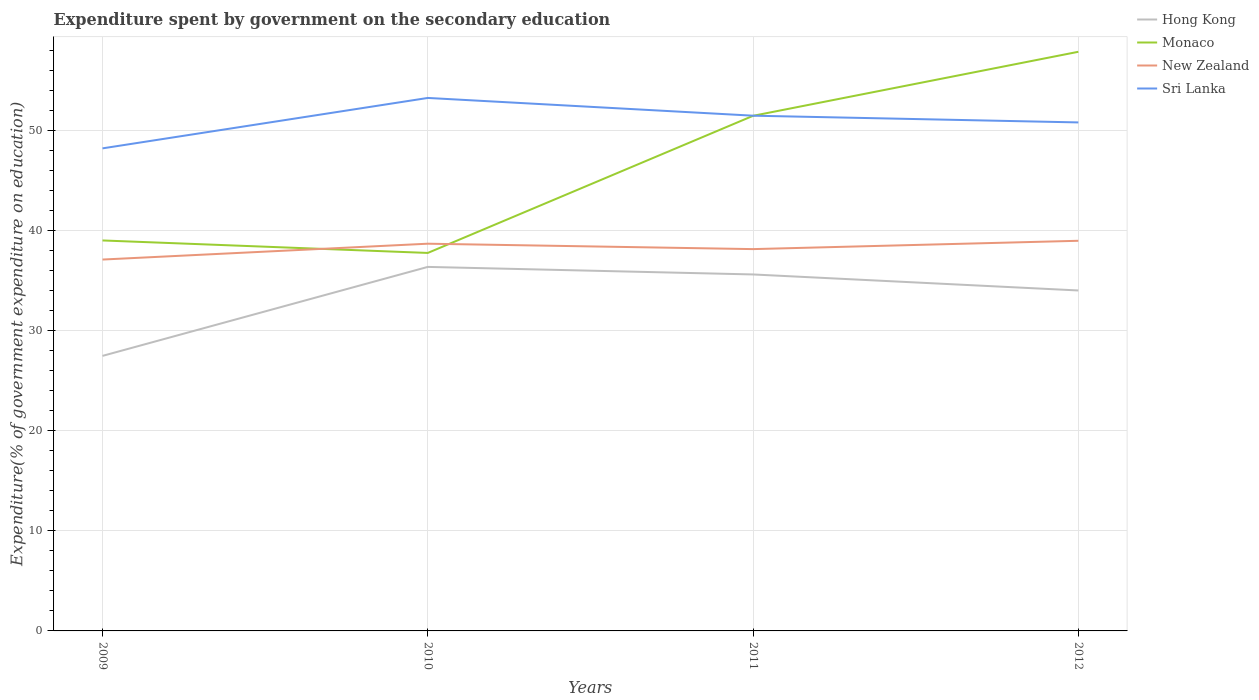Across all years, what is the maximum expenditure spent by government on the secondary education in New Zealand?
Your response must be concise. 37.09. What is the total expenditure spent by government on the secondary education in Monaco in the graph?
Provide a succinct answer. -6.39. What is the difference between the highest and the second highest expenditure spent by government on the secondary education in Hong Kong?
Your answer should be very brief. 8.89. What is the difference between the highest and the lowest expenditure spent by government on the secondary education in Monaco?
Make the answer very short. 2. How many years are there in the graph?
Provide a succinct answer. 4. Does the graph contain grids?
Make the answer very short. Yes. Where does the legend appear in the graph?
Offer a terse response. Top right. What is the title of the graph?
Make the answer very short. Expenditure spent by government on the secondary education. Does "Norway" appear as one of the legend labels in the graph?
Ensure brevity in your answer.  No. What is the label or title of the Y-axis?
Your answer should be compact. Expenditure(% of government expenditure on education). What is the Expenditure(% of government expenditure on education) of Hong Kong in 2009?
Your answer should be compact. 27.47. What is the Expenditure(% of government expenditure on education) in Monaco in 2009?
Your answer should be very brief. 38.99. What is the Expenditure(% of government expenditure on education) of New Zealand in 2009?
Ensure brevity in your answer.  37.09. What is the Expenditure(% of government expenditure on education) of Sri Lanka in 2009?
Give a very brief answer. 48.19. What is the Expenditure(% of government expenditure on education) in Hong Kong in 2010?
Make the answer very short. 36.35. What is the Expenditure(% of government expenditure on education) in Monaco in 2010?
Keep it short and to the point. 37.75. What is the Expenditure(% of government expenditure on education) of New Zealand in 2010?
Provide a short and direct response. 38.67. What is the Expenditure(% of government expenditure on education) of Sri Lanka in 2010?
Your answer should be compact. 53.22. What is the Expenditure(% of government expenditure on education) of Hong Kong in 2011?
Make the answer very short. 35.6. What is the Expenditure(% of government expenditure on education) in Monaco in 2011?
Offer a terse response. 51.44. What is the Expenditure(% of government expenditure on education) of New Zealand in 2011?
Provide a succinct answer. 38.13. What is the Expenditure(% of government expenditure on education) of Sri Lanka in 2011?
Keep it short and to the point. 51.45. What is the Expenditure(% of government expenditure on education) in Hong Kong in 2012?
Make the answer very short. 34. What is the Expenditure(% of government expenditure on education) of Monaco in 2012?
Provide a succinct answer. 57.83. What is the Expenditure(% of government expenditure on education) of New Zealand in 2012?
Your answer should be very brief. 38.96. What is the Expenditure(% of government expenditure on education) of Sri Lanka in 2012?
Your answer should be very brief. 50.78. Across all years, what is the maximum Expenditure(% of government expenditure on education) in Hong Kong?
Offer a very short reply. 36.35. Across all years, what is the maximum Expenditure(% of government expenditure on education) of Monaco?
Your response must be concise. 57.83. Across all years, what is the maximum Expenditure(% of government expenditure on education) of New Zealand?
Your answer should be compact. 38.96. Across all years, what is the maximum Expenditure(% of government expenditure on education) in Sri Lanka?
Your response must be concise. 53.22. Across all years, what is the minimum Expenditure(% of government expenditure on education) of Hong Kong?
Offer a terse response. 27.47. Across all years, what is the minimum Expenditure(% of government expenditure on education) of Monaco?
Ensure brevity in your answer.  37.75. Across all years, what is the minimum Expenditure(% of government expenditure on education) of New Zealand?
Your response must be concise. 37.09. Across all years, what is the minimum Expenditure(% of government expenditure on education) of Sri Lanka?
Your response must be concise. 48.19. What is the total Expenditure(% of government expenditure on education) in Hong Kong in the graph?
Provide a short and direct response. 133.41. What is the total Expenditure(% of government expenditure on education) of Monaco in the graph?
Provide a short and direct response. 186.01. What is the total Expenditure(% of government expenditure on education) in New Zealand in the graph?
Give a very brief answer. 152.84. What is the total Expenditure(% of government expenditure on education) of Sri Lanka in the graph?
Make the answer very short. 203.65. What is the difference between the Expenditure(% of government expenditure on education) in Hong Kong in 2009 and that in 2010?
Offer a very short reply. -8.89. What is the difference between the Expenditure(% of government expenditure on education) in Monaco in 2009 and that in 2010?
Offer a very short reply. 1.25. What is the difference between the Expenditure(% of government expenditure on education) in New Zealand in 2009 and that in 2010?
Your response must be concise. -1.58. What is the difference between the Expenditure(% of government expenditure on education) in Sri Lanka in 2009 and that in 2010?
Provide a short and direct response. -5.04. What is the difference between the Expenditure(% of government expenditure on education) of Hong Kong in 2009 and that in 2011?
Offer a terse response. -8.13. What is the difference between the Expenditure(% of government expenditure on education) of Monaco in 2009 and that in 2011?
Ensure brevity in your answer.  -12.45. What is the difference between the Expenditure(% of government expenditure on education) of New Zealand in 2009 and that in 2011?
Make the answer very short. -1.04. What is the difference between the Expenditure(% of government expenditure on education) of Sri Lanka in 2009 and that in 2011?
Ensure brevity in your answer.  -3.26. What is the difference between the Expenditure(% of government expenditure on education) in Hong Kong in 2009 and that in 2012?
Provide a short and direct response. -6.53. What is the difference between the Expenditure(% of government expenditure on education) in Monaco in 2009 and that in 2012?
Provide a succinct answer. -18.84. What is the difference between the Expenditure(% of government expenditure on education) in New Zealand in 2009 and that in 2012?
Make the answer very short. -1.87. What is the difference between the Expenditure(% of government expenditure on education) of Sri Lanka in 2009 and that in 2012?
Keep it short and to the point. -2.59. What is the difference between the Expenditure(% of government expenditure on education) of Hong Kong in 2010 and that in 2011?
Offer a very short reply. 0.75. What is the difference between the Expenditure(% of government expenditure on education) in Monaco in 2010 and that in 2011?
Your answer should be very brief. -13.69. What is the difference between the Expenditure(% of government expenditure on education) of New Zealand in 2010 and that in 2011?
Offer a very short reply. 0.54. What is the difference between the Expenditure(% of government expenditure on education) of Sri Lanka in 2010 and that in 2011?
Your response must be concise. 1.77. What is the difference between the Expenditure(% of government expenditure on education) in Hong Kong in 2010 and that in 2012?
Provide a short and direct response. 2.35. What is the difference between the Expenditure(% of government expenditure on education) of Monaco in 2010 and that in 2012?
Your response must be concise. -20.09. What is the difference between the Expenditure(% of government expenditure on education) of New Zealand in 2010 and that in 2012?
Ensure brevity in your answer.  -0.29. What is the difference between the Expenditure(% of government expenditure on education) in Sri Lanka in 2010 and that in 2012?
Offer a very short reply. 2.44. What is the difference between the Expenditure(% of government expenditure on education) of Hong Kong in 2011 and that in 2012?
Your response must be concise. 1.6. What is the difference between the Expenditure(% of government expenditure on education) of Monaco in 2011 and that in 2012?
Your answer should be very brief. -6.39. What is the difference between the Expenditure(% of government expenditure on education) of New Zealand in 2011 and that in 2012?
Make the answer very short. -0.83. What is the difference between the Expenditure(% of government expenditure on education) of Sri Lanka in 2011 and that in 2012?
Offer a terse response. 0.67. What is the difference between the Expenditure(% of government expenditure on education) of Hong Kong in 2009 and the Expenditure(% of government expenditure on education) of Monaco in 2010?
Your response must be concise. -10.28. What is the difference between the Expenditure(% of government expenditure on education) in Hong Kong in 2009 and the Expenditure(% of government expenditure on education) in New Zealand in 2010?
Your response must be concise. -11.2. What is the difference between the Expenditure(% of government expenditure on education) of Hong Kong in 2009 and the Expenditure(% of government expenditure on education) of Sri Lanka in 2010?
Your answer should be very brief. -25.76. What is the difference between the Expenditure(% of government expenditure on education) of Monaco in 2009 and the Expenditure(% of government expenditure on education) of New Zealand in 2010?
Provide a succinct answer. 0.33. What is the difference between the Expenditure(% of government expenditure on education) in Monaco in 2009 and the Expenditure(% of government expenditure on education) in Sri Lanka in 2010?
Your answer should be compact. -14.23. What is the difference between the Expenditure(% of government expenditure on education) in New Zealand in 2009 and the Expenditure(% of government expenditure on education) in Sri Lanka in 2010?
Your answer should be compact. -16.14. What is the difference between the Expenditure(% of government expenditure on education) of Hong Kong in 2009 and the Expenditure(% of government expenditure on education) of Monaco in 2011?
Provide a short and direct response. -23.97. What is the difference between the Expenditure(% of government expenditure on education) in Hong Kong in 2009 and the Expenditure(% of government expenditure on education) in New Zealand in 2011?
Your answer should be very brief. -10.66. What is the difference between the Expenditure(% of government expenditure on education) in Hong Kong in 2009 and the Expenditure(% of government expenditure on education) in Sri Lanka in 2011?
Give a very brief answer. -23.99. What is the difference between the Expenditure(% of government expenditure on education) in Monaco in 2009 and the Expenditure(% of government expenditure on education) in New Zealand in 2011?
Offer a very short reply. 0.87. What is the difference between the Expenditure(% of government expenditure on education) in Monaco in 2009 and the Expenditure(% of government expenditure on education) in Sri Lanka in 2011?
Provide a short and direct response. -12.46. What is the difference between the Expenditure(% of government expenditure on education) of New Zealand in 2009 and the Expenditure(% of government expenditure on education) of Sri Lanka in 2011?
Your response must be concise. -14.37. What is the difference between the Expenditure(% of government expenditure on education) in Hong Kong in 2009 and the Expenditure(% of government expenditure on education) in Monaco in 2012?
Keep it short and to the point. -30.37. What is the difference between the Expenditure(% of government expenditure on education) in Hong Kong in 2009 and the Expenditure(% of government expenditure on education) in New Zealand in 2012?
Your answer should be very brief. -11.49. What is the difference between the Expenditure(% of government expenditure on education) in Hong Kong in 2009 and the Expenditure(% of government expenditure on education) in Sri Lanka in 2012?
Make the answer very short. -23.31. What is the difference between the Expenditure(% of government expenditure on education) in Monaco in 2009 and the Expenditure(% of government expenditure on education) in New Zealand in 2012?
Make the answer very short. 0.03. What is the difference between the Expenditure(% of government expenditure on education) in Monaco in 2009 and the Expenditure(% of government expenditure on education) in Sri Lanka in 2012?
Your answer should be very brief. -11.79. What is the difference between the Expenditure(% of government expenditure on education) of New Zealand in 2009 and the Expenditure(% of government expenditure on education) of Sri Lanka in 2012?
Offer a very short reply. -13.69. What is the difference between the Expenditure(% of government expenditure on education) of Hong Kong in 2010 and the Expenditure(% of government expenditure on education) of Monaco in 2011?
Offer a very short reply. -15.09. What is the difference between the Expenditure(% of government expenditure on education) in Hong Kong in 2010 and the Expenditure(% of government expenditure on education) in New Zealand in 2011?
Your response must be concise. -1.78. What is the difference between the Expenditure(% of government expenditure on education) of Hong Kong in 2010 and the Expenditure(% of government expenditure on education) of Sri Lanka in 2011?
Offer a very short reply. -15.1. What is the difference between the Expenditure(% of government expenditure on education) in Monaco in 2010 and the Expenditure(% of government expenditure on education) in New Zealand in 2011?
Offer a terse response. -0.38. What is the difference between the Expenditure(% of government expenditure on education) of Monaco in 2010 and the Expenditure(% of government expenditure on education) of Sri Lanka in 2011?
Offer a very short reply. -13.71. What is the difference between the Expenditure(% of government expenditure on education) of New Zealand in 2010 and the Expenditure(% of government expenditure on education) of Sri Lanka in 2011?
Provide a short and direct response. -12.78. What is the difference between the Expenditure(% of government expenditure on education) of Hong Kong in 2010 and the Expenditure(% of government expenditure on education) of Monaco in 2012?
Your response must be concise. -21.48. What is the difference between the Expenditure(% of government expenditure on education) in Hong Kong in 2010 and the Expenditure(% of government expenditure on education) in New Zealand in 2012?
Offer a very short reply. -2.61. What is the difference between the Expenditure(% of government expenditure on education) of Hong Kong in 2010 and the Expenditure(% of government expenditure on education) of Sri Lanka in 2012?
Ensure brevity in your answer.  -14.43. What is the difference between the Expenditure(% of government expenditure on education) of Monaco in 2010 and the Expenditure(% of government expenditure on education) of New Zealand in 2012?
Keep it short and to the point. -1.21. What is the difference between the Expenditure(% of government expenditure on education) in Monaco in 2010 and the Expenditure(% of government expenditure on education) in Sri Lanka in 2012?
Provide a succinct answer. -13.03. What is the difference between the Expenditure(% of government expenditure on education) in New Zealand in 2010 and the Expenditure(% of government expenditure on education) in Sri Lanka in 2012?
Your answer should be very brief. -12.11. What is the difference between the Expenditure(% of government expenditure on education) in Hong Kong in 2011 and the Expenditure(% of government expenditure on education) in Monaco in 2012?
Ensure brevity in your answer.  -22.24. What is the difference between the Expenditure(% of government expenditure on education) of Hong Kong in 2011 and the Expenditure(% of government expenditure on education) of New Zealand in 2012?
Your answer should be compact. -3.36. What is the difference between the Expenditure(% of government expenditure on education) in Hong Kong in 2011 and the Expenditure(% of government expenditure on education) in Sri Lanka in 2012?
Provide a succinct answer. -15.18. What is the difference between the Expenditure(% of government expenditure on education) in Monaco in 2011 and the Expenditure(% of government expenditure on education) in New Zealand in 2012?
Give a very brief answer. 12.48. What is the difference between the Expenditure(% of government expenditure on education) in Monaco in 2011 and the Expenditure(% of government expenditure on education) in Sri Lanka in 2012?
Make the answer very short. 0.66. What is the difference between the Expenditure(% of government expenditure on education) of New Zealand in 2011 and the Expenditure(% of government expenditure on education) of Sri Lanka in 2012?
Make the answer very short. -12.65. What is the average Expenditure(% of government expenditure on education) in Hong Kong per year?
Make the answer very short. 33.35. What is the average Expenditure(% of government expenditure on education) of Monaco per year?
Make the answer very short. 46.5. What is the average Expenditure(% of government expenditure on education) of New Zealand per year?
Your answer should be compact. 38.21. What is the average Expenditure(% of government expenditure on education) of Sri Lanka per year?
Offer a terse response. 50.91. In the year 2009, what is the difference between the Expenditure(% of government expenditure on education) of Hong Kong and Expenditure(% of government expenditure on education) of Monaco?
Offer a terse response. -11.53. In the year 2009, what is the difference between the Expenditure(% of government expenditure on education) in Hong Kong and Expenditure(% of government expenditure on education) in New Zealand?
Offer a very short reply. -9.62. In the year 2009, what is the difference between the Expenditure(% of government expenditure on education) in Hong Kong and Expenditure(% of government expenditure on education) in Sri Lanka?
Provide a short and direct response. -20.72. In the year 2009, what is the difference between the Expenditure(% of government expenditure on education) in Monaco and Expenditure(% of government expenditure on education) in New Zealand?
Your response must be concise. 1.91. In the year 2009, what is the difference between the Expenditure(% of government expenditure on education) in Monaco and Expenditure(% of government expenditure on education) in Sri Lanka?
Provide a short and direct response. -9.2. In the year 2009, what is the difference between the Expenditure(% of government expenditure on education) in New Zealand and Expenditure(% of government expenditure on education) in Sri Lanka?
Your response must be concise. -11.1. In the year 2010, what is the difference between the Expenditure(% of government expenditure on education) in Hong Kong and Expenditure(% of government expenditure on education) in Monaco?
Give a very brief answer. -1.4. In the year 2010, what is the difference between the Expenditure(% of government expenditure on education) in Hong Kong and Expenditure(% of government expenditure on education) in New Zealand?
Keep it short and to the point. -2.32. In the year 2010, what is the difference between the Expenditure(% of government expenditure on education) in Hong Kong and Expenditure(% of government expenditure on education) in Sri Lanka?
Give a very brief answer. -16.87. In the year 2010, what is the difference between the Expenditure(% of government expenditure on education) in Monaco and Expenditure(% of government expenditure on education) in New Zealand?
Your response must be concise. -0.92. In the year 2010, what is the difference between the Expenditure(% of government expenditure on education) of Monaco and Expenditure(% of government expenditure on education) of Sri Lanka?
Offer a terse response. -15.48. In the year 2010, what is the difference between the Expenditure(% of government expenditure on education) of New Zealand and Expenditure(% of government expenditure on education) of Sri Lanka?
Make the answer very short. -14.56. In the year 2011, what is the difference between the Expenditure(% of government expenditure on education) in Hong Kong and Expenditure(% of government expenditure on education) in Monaco?
Provide a succinct answer. -15.84. In the year 2011, what is the difference between the Expenditure(% of government expenditure on education) of Hong Kong and Expenditure(% of government expenditure on education) of New Zealand?
Provide a succinct answer. -2.53. In the year 2011, what is the difference between the Expenditure(% of government expenditure on education) in Hong Kong and Expenditure(% of government expenditure on education) in Sri Lanka?
Provide a succinct answer. -15.85. In the year 2011, what is the difference between the Expenditure(% of government expenditure on education) of Monaco and Expenditure(% of government expenditure on education) of New Zealand?
Your response must be concise. 13.31. In the year 2011, what is the difference between the Expenditure(% of government expenditure on education) in Monaco and Expenditure(% of government expenditure on education) in Sri Lanka?
Ensure brevity in your answer.  -0.01. In the year 2011, what is the difference between the Expenditure(% of government expenditure on education) in New Zealand and Expenditure(% of government expenditure on education) in Sri Lanka?
Give a very brief answer. -13.32. In the year 2012, what is the difference between the Expenditure(% of government expenditure on education) of Hong Kong and Expenditure(% of government expenditure on education) of Monaco?
Make the answer very short. -23.84. In the year 2012, what is the difference between the Expenditure(% of government expenditure on education) in Hong Kong and Expenditure(% of government expenditure on education) in New Zealand?
Offer a very short reply. -4.96. In the year 2012, what is the difference between the Expenditure(% of government expenditure on education) of Hong Kong and Expenditure(% of government expenditure on education) of Sri Lanka?
Offer a very short reply. -16.78. In the year 2012, what is the difference between the Expenditure(% of government expenditure on education) of Monaco and Expenditure(% of government expenditure on education) of New Zealand?
Your response must be concise. 18.87. In the year 2012, what is the difference between the Expenditure(% of government expenditure on education) of Monaco and Expenditure(% of government expenditure on education) of Sri Lanka?
Provide a succinct answer. 7.05. In the year 2012, what is the difference between the Expenditure(% of government expenditure on education) in New Zealand and Expenditure(% of government expenditure on education) in Sri Lanka?
Provide a succinct answer. -11.82. What is the ratio of the Expenditure(% of government expenditure on education) of Hong Kong in 2009 to that in 2010?
Provide a short and direct response. 0.76. What is the ratio of the Expenditure(% of government expenditure on education) in Monaco in 2009 to that in 2010?
Offer a terse response. 1.03. What is the ratio of the Expenditure(% of government expenditure on education) in New Zealand in 2009 to that in 2010?
Offer a terse response. 0.96. What is the ratio of the Expenditure(% of government expenditure on education) in Sri Lanka in 2009 to that in 2010?
Provide a succinct answer. 0.91. What is the ratio of the Expenditure(% of government expenditure on education) in Hong Kong in 2009 to that in 2011?
Give a very brief answer. 0.77. What is the ratio of the Expenditure(% of government expenditure on education) in Monaco in 2009 to that in 2011?
Your response must be concise. 0.76. What is the ratio of the Expenditure(% of government expenditure on education) of New Zealand in 2009 to that in 2011?
Give a very brief answer. 0.97. What is the ratio of the Expenditure(% of government expenditure on education) of Sri Lanka in 2009 to that in 2011?
Offer a very short reply. 0.94. What is the ratio of the Expenditure(% of government expenditure on education) of Hong Kong in 2009 to that in 2012?
Offer a terse response. 0.81. What is the ratio of the Expenditure(% of government expenditure on education) of Monaco in 2009 to that in 2012?
Make the answer very short. 0.67. What is the ratio of the Expenditure(% of government expenditure on education) of New Zealand in 2009 to that in 2012?
Keep it short and to the point. 0.95. What is the ratio of the Expenditure(% of government expenditure on education) in Sri Lanka in 2009 to that in 2012?
Offer a very short reply. 0.95. What is the ratio of the Expenditure(% of government expenditure on education) of Hong Kong in 2010 to that in 2011?
Your response must be concise. 1.02. What is the ratio of the Expenditure(% of government expenditure on education) of Monaco in 2010 to that in 2011?
Your response must be concise. 0.73. What is the ratio of the Expenditure(% of government expenditure on education) in New Zealand in 2010 to that in 2011?
Provide a short and direct response. 1.01. What is the ratio of the Expenditure(% of government expenditure on education) in Sri Lanka in 2010 to that in 2011?
Make the answer very short. 1.03. What is the ratio of the Expenditure(% of government expenditure on education) in Hong Kong in 2010 to that in 2012?
Ensure brevity in your answer.  1.07. What is the ratio of the Expenditure(% of government expenditure on education) of Monaco in 2010 to that in 2012?
Keep it short and to the point. 0.65. What is the ratio of the Expenditure(% of government expenditure on education) of Sri Lanka in 2010 to that in 2012?
Your answer should be very brief. 1.05. What is the ratio of the Expenditure(% of government expenditure on education) in Hong Kong in 2011 to that in 2012?
Ensure brevity in your answer.  1.05. What is the ratio of the Expenditure(% of government expenditure on education) of Monaco in 2011 to that in 2012?
Your answer should be compact. 0.89. What is the ratio of the Expenditure(% of government expenditure on education) of New Zealand in 2011 to that in 2012?
Make the answer very short. 0.98. What is the ratio of the Expenditure(% of government expenditure on education) of Sri Lanka in 2011 to that in 2012?
Keep it short and to the point. 1.01. What is the difference between the highest and the second highest Expenditure(% of government expenditure on education) in Hong Kong?
Make the answer very short. 0.75. What is the difference between the highest and the second highest Expenditure(% of government expenditure on education) in Monaco?
Offer a very short reply. 6.39. What is the difference between the highest and the second highest Expenditure(% of government expenditure on education) in New Zealand?
Make the answer very short. 0.29. What is the difference between the highest and the second highest Expenditure(% of government expenditure on education) of Sri Lanka?
Give a very brief answer. 1.77. What is the difference between the highest and the lowest Expenditure(% of government expenditure on education) of Hong Kong?
Your response must be concise. 8.89. What is the difference between the highest and the lowest Expenditure(% of government expenditure on education) in Monaco?
Ensure brevity in your answer.  20.09. What is the difference between the highest and the lowest Expenditure(% of government expenditure on education) in New Zealand?
Make the answer very short. 1.87. What is the difference between the highest and the lowest Expenditure(% of government expenditure on education) in Sri Lanka?
Your response must be concise. 5.04. 